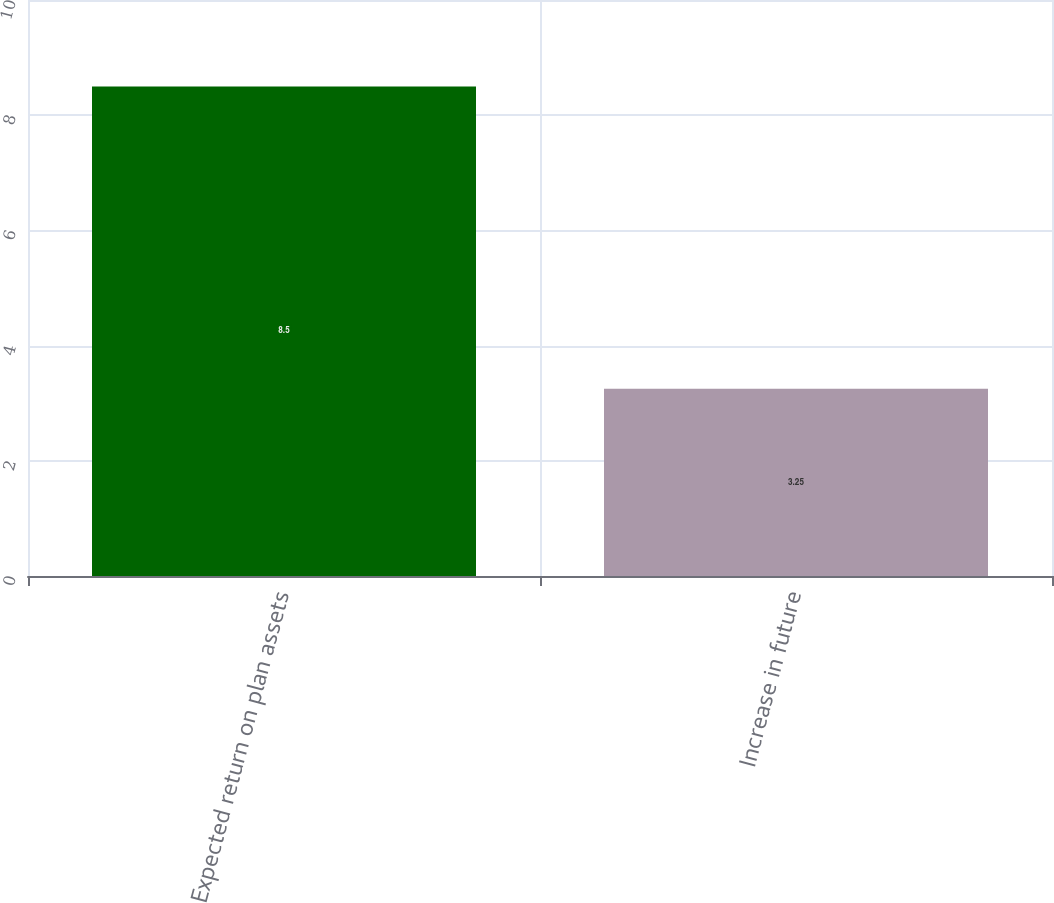Convert chart. <chart><loc_0><loc_0><loc_500><loc_500><bar_chart><fcel>Expected return on plan assets<fcel>Increase in future<nl><fcel>8.5<fcel>3.25<nl></chart> 